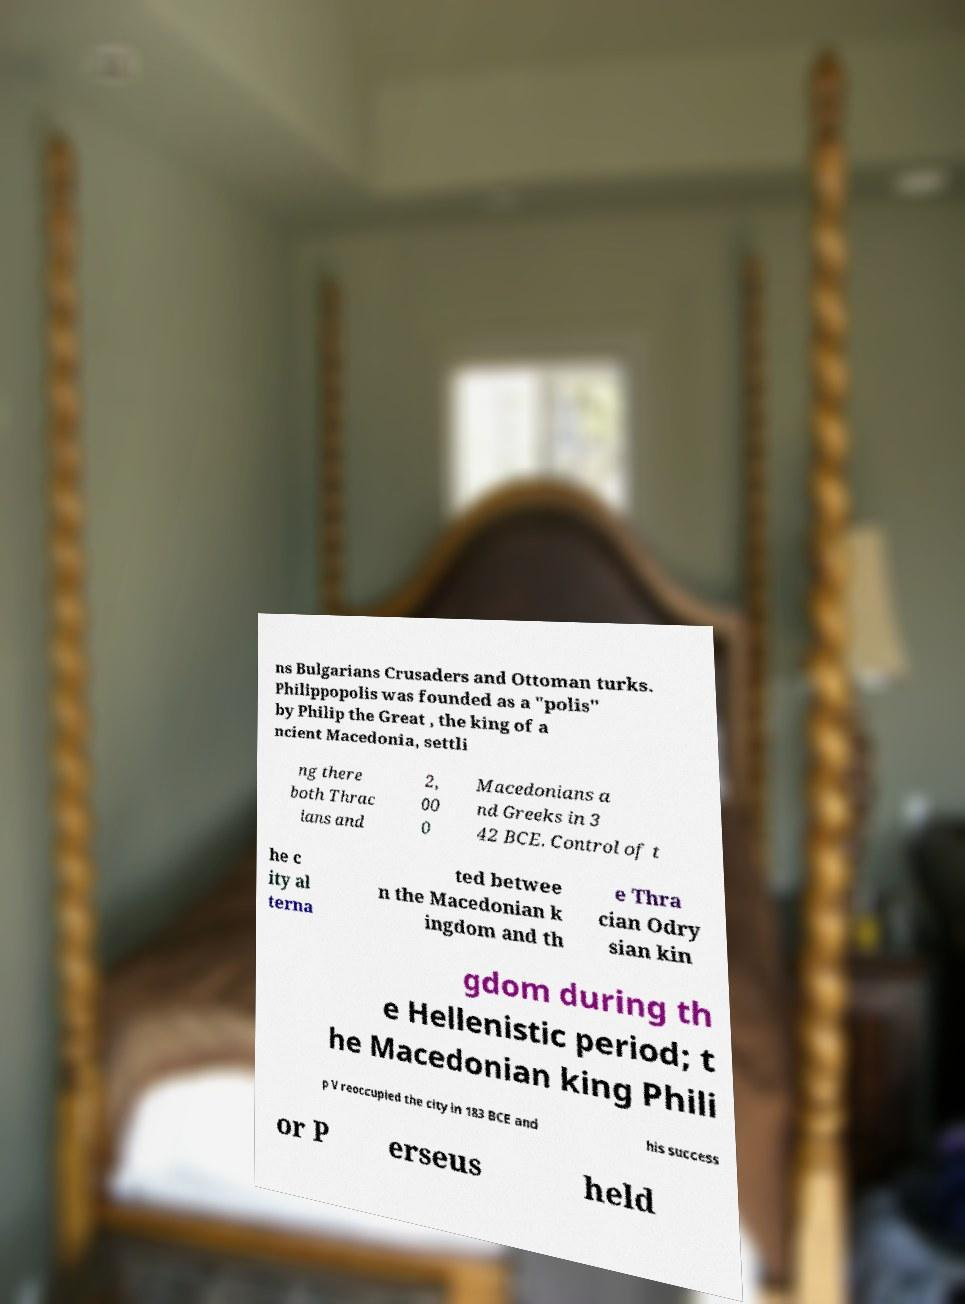Could you extract and type out the text from this image? ns Bulgarians Crusaders and Ottoman turks. Philippopolis was founded as a "polis" by Philip the Great , the king of a ncient Macedonia, settli ng there both Thrac ians and 2, 00 0 Macedonians a nd Greeks in 3 42 BCE. Control of t he c ity al terna ted betwee n the Macedonian k ingdom and th e Thra cian Odry sian kin gdom during th e Hellenistic period; t he Macedonian king Phili p V reoccupied the city in 183 BCE and his success or P erseus held 